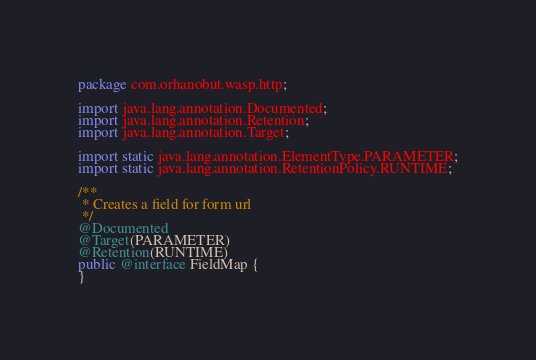<code> <loc_0><loc_0><loc_500><loc_500><_Java_>package com.orhanobut.wasp.http;

import java.lang.annotation.Documented;
import java.lang.annotation.Retention;
import java.lang.annotation.Target;

import static java.lang.annotation.ElementType.PARAMETER;
import static java.lang.annotation.RetentionPolicy.RUNTIME;

/**
 * Creates a field for form url
 */
@Documented
@Target(PARAMETER)
@Retention(RUNTIME)
public @interface FieldMap {
}
</code> 